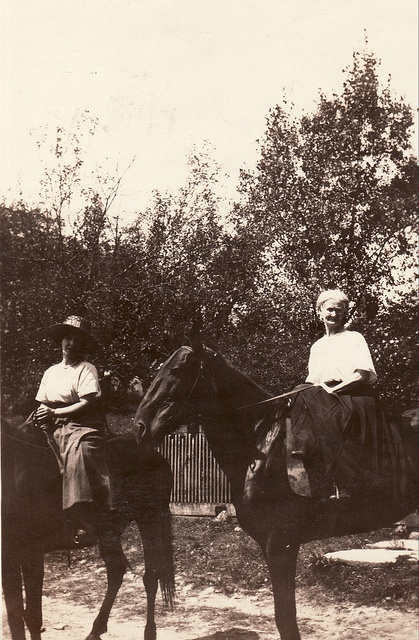Describe the objects in this image and their specific colors. I can see horse in ivory, black, gray, and maroon tones, horse in ivory, black, and gray tones, people in ivory, black, and gray tones, and people in ivory, black, and gray tones in this image. 